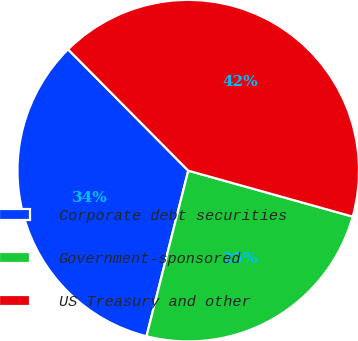Convert chart. <chart><loc_0><loc_0><loc_500><loc_500><pie_chart><fcel>Corporate debt securities<fcel>Government-sponsored<fcel>US Treasury and other<nl><fcel>33.64%<fcel>24.59%<fcel>41.76%<nl></chart> 